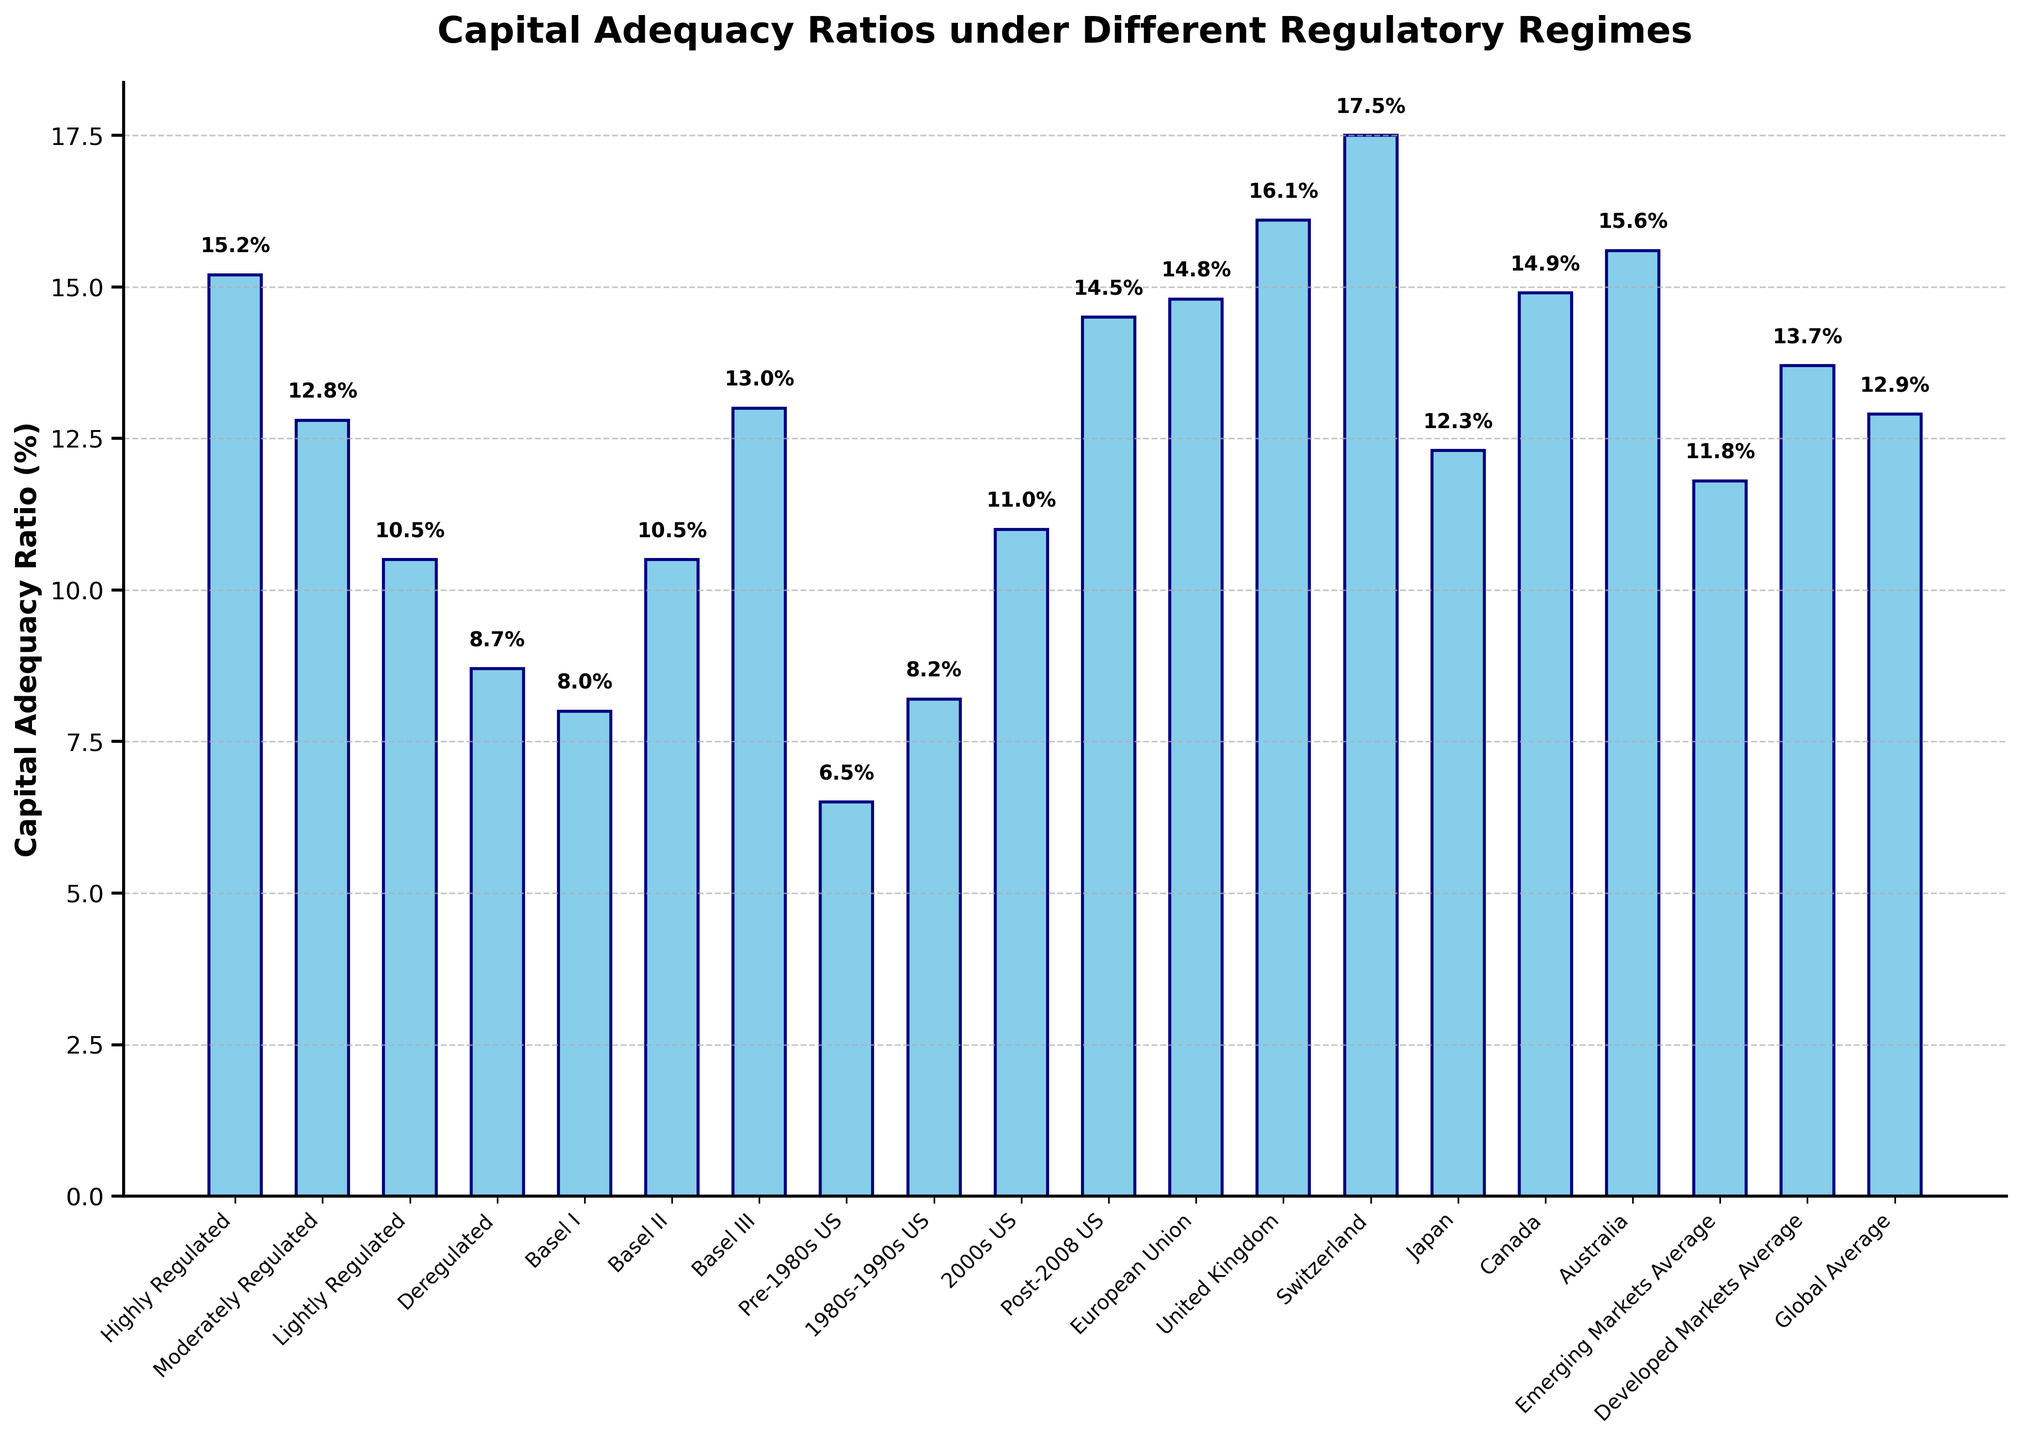Which regulatory regime has the highest capital adequacy ratio? The bar representing "Switzerland" is the tallest, indicating the highest capital adequacy ratio.
Answer: Switzerland How much lower is the capital adequacy ratio for "Deregulated" compared to "Highly Regulated"? The bar for "Highly Regulated" is at 15.2%, and the bar for "Deregulated" is at 8.7%. The difference is 15.2% - 8.7% = 6.5%.
Answer: 6.5% What is the average capital adequacy ratio of "Highly Regulated", "Moderately Regulated", and "Lightly Regulated"? Adding the ratios: 15.2% + 12.8% + 10.5% = 38.5%. Dividing by 3, the average is 38.5% / 3 ≈ 12.83%.
Answer: 12.83% Which regulatory regime has a capital adequacy ratio closest to the "Global Average"? "Post-2008 US" with 14.5% is the closest to the "Global Average" of 12.9%.
Answer: Post-2008 US Which region has a higher capital adequacy ratio: "Australia" or "Canada"? The bar for "Australia" is at 15.6%, and the bar for "Canada" is at 14.9%. Australia has a higher capital adequacy ratio.
Answer: Australia How many regulatory regimes have a capital adequacy ratio greater than 12.0%? Identifying bars greater than 12.0%: "Highly Regulated", "Basel III", "Post-2008 US", "European Union", "United Kingdom", "Switzerland", "Japan", "Canada", "Australia". There are 9 regimes.
Answer: 9 What is the collective capital adequacy ratio of "Emerging Markets Average" and "Developed Markets Average"? Summing the ratios: 11.8% + 13.7% = 25.5%.
Answer: 25.5% Which has a larger capital adequacy ratio increase compared to the "Pre-1980s US": "1980s-1990s US" or "Basel II"? The increase for "1980s-1990s US" is 8.2% - 6.5% = 1.7%. The increase for "Basel II" is 10.5% - 6.5% = 4.0%. Basel II has a larger increase.
Answer: Basel II Which regulatory regime has the median capital adequacy ratio? Sorting the ratios in ascending order and finding the middle value: "Global Average" with 12.9% is the median.
Answer: Global Average 